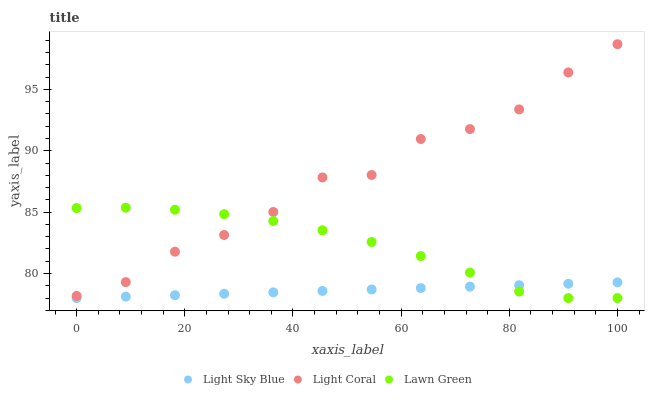Does Light Sky Blue have the minimum area under the curve?
Answer yes or no. Yes. Does Light Coral have the maximum area under the curve?
Answer yes or no. Yes. Does Lawn Green have the minimum area under the curve?
Answer yes or no. No. Does Lawn Green have the maximum area under the curve?
Answer yes or no. No. Is Light Sky Blue the smoothest?
Answer yes or no. Yes. Is Light Coral the roughest?
Answer yes or no. Yes. Is Lawn Green the smoothest?
Answer yes or no. No. Is Lawn Green the roughest?
Answer yes or no. No. Does Lawn Green have the lowest value?
Answer yes or no. Yes. Does Light Coral have the highest value?
Answer yes or no. Yes. Does Lawn Green have the highest value?
Answer yes or no. No. Is Light Sky Blue less than Light Coral?
Answer yes or no. Yes. Is Light Coral greater than Light Sky Blue?
Answer yes or no. Yes. Does Light Coral intersect Lawn Green?
Answer yes or no. Yes. Is Light Coral less than Lawn Green?
Answer yes or no. No. Is Light Coral greater than Lawn Green?
Answer yes or no. No. Does Light Sky Blue intersect Light Coral?
Answer yes or no. No. 